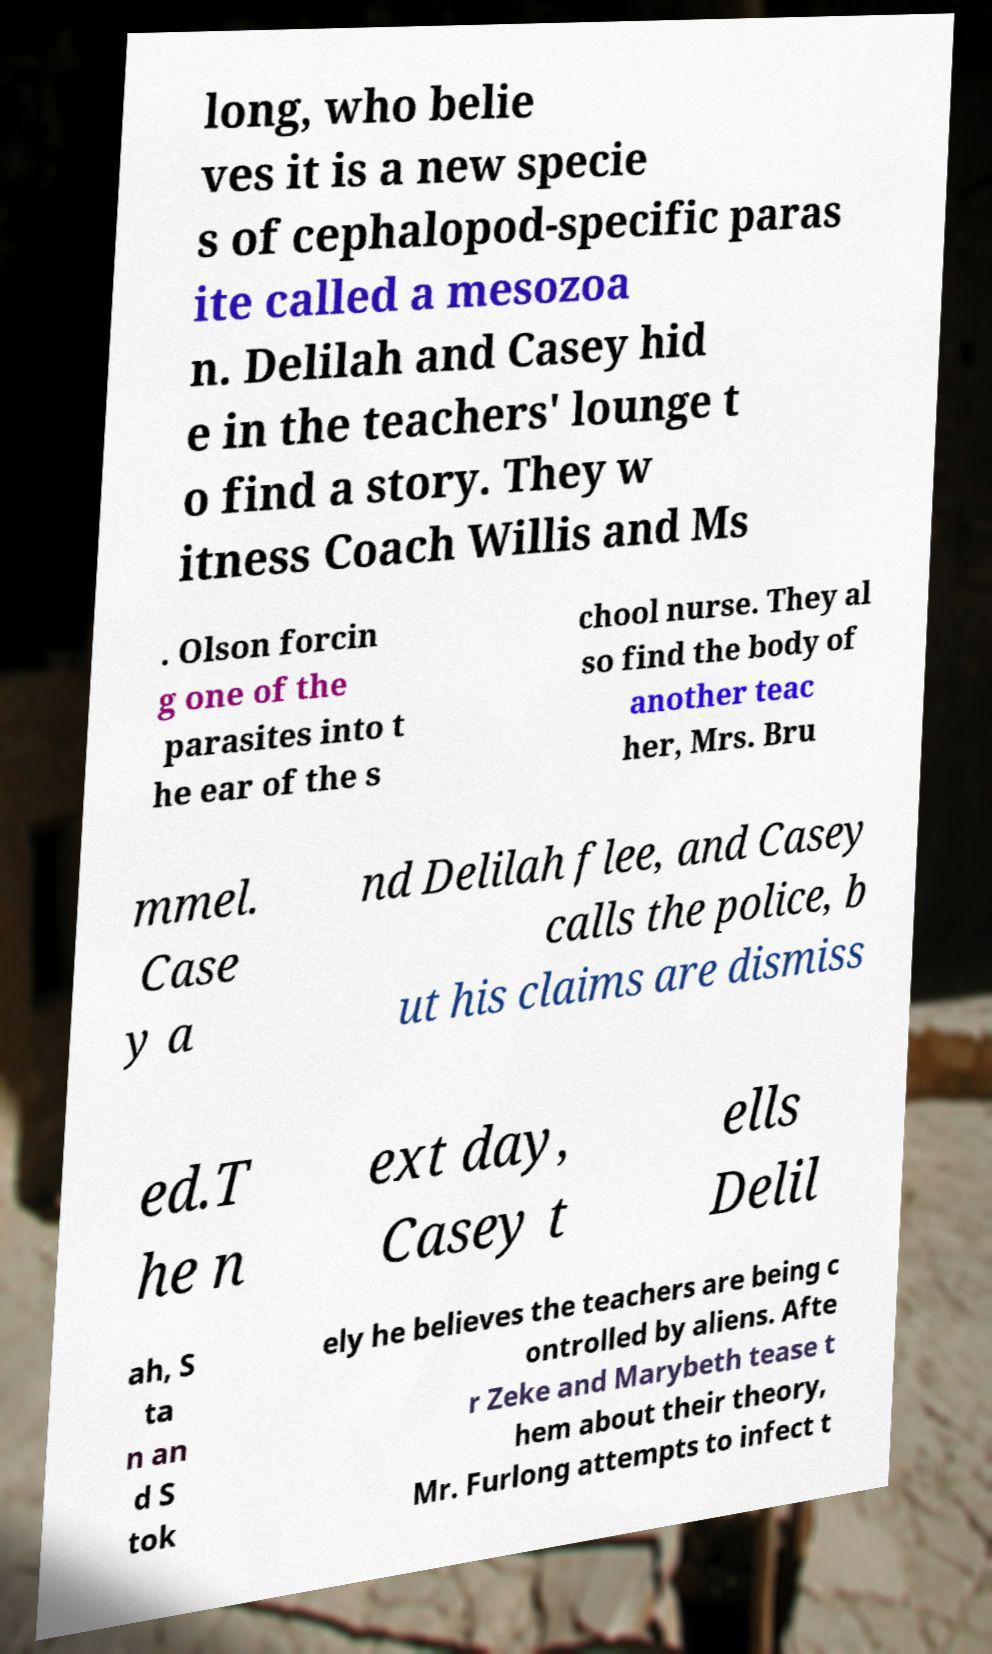I need the written content from this picture converted into text. Can you do that? long, who belie ves it is a new specie s of cephalopod-specific paras ite called a mesozoa n. Delilah and Casey hid e in the teachers' lounge t o find a story. They w itness Coach Willis and Ms . Olson forcin g one of the parasites into t he ear of the s chool nurse. They al so find the body of another teac her, Mrs. Bru mmel. Case y a nd Delilah flee, and Casey calls the police, b ut his claims are dismiss ed.T he n ext day, Casey t ells Delil ah, S ta n an d S tok ely he believes the teachers are being c ontrolled by aliens. Afte r Zeke and Marybeth tease t hem about their theory, Mr. Furlong attempts to infect t 